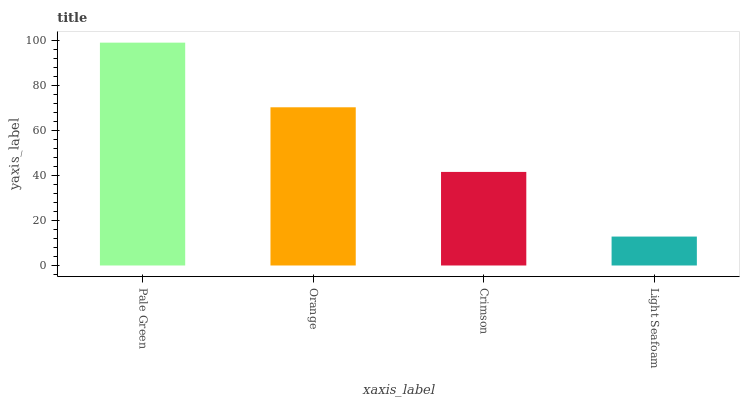Is Light Seafoam the minimum?
Answer yes or no. Yes. Is Pale Green the maximum?
Answer yes or no. Yes. Is Orange the minimum?
Answer yes or no. No. Is Orange the maximum?
Answer yes or no. No. Is Pale Green greater than Orange?
Answer yes or no. Yes. Is Orange less than Pale Green?
Answer yes or no. Yes. Is Orange greater than Pale Green?
Answer yes or no. No. Is Pale Green less than Orange?
Answer yes or no. No. Is Orange the high median?
Answer yes or no. Yes. Is Crimson the low median?
Answer yes or no. Yes. Is Light Seafoam the high median?
Answer yes or no. No. Is Pale Green the low median?
Answer yes or no. No. 